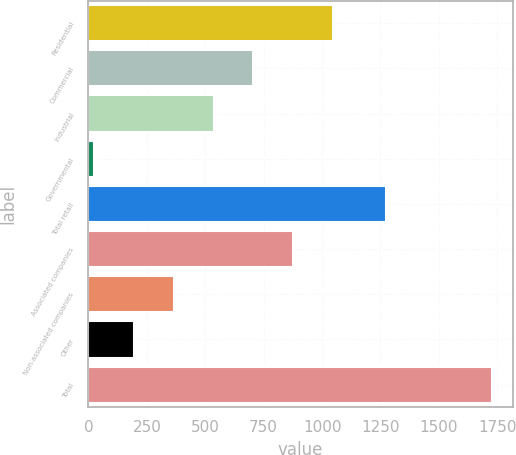<chart> <loc_0><loc_0><loc_500><loc_500><bar_chart><fcel>Residential<fcel>Commercial<fcel>Industrial<fcel>Governmental<fcel>Total retail<fcel>Associated companies<fcel>Non-associated companies<fcel>Other<fcel>Total<nl><fcel>1047<fcel>706<fcel>535.5<fcel>24<fcel>1272<fcel>876.5<fcel>365<fcel>194.5<fcel>1729<nl></chart> 